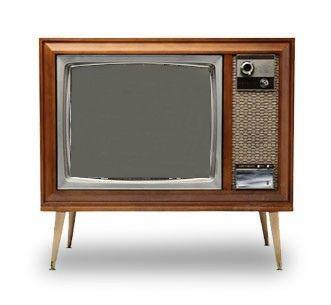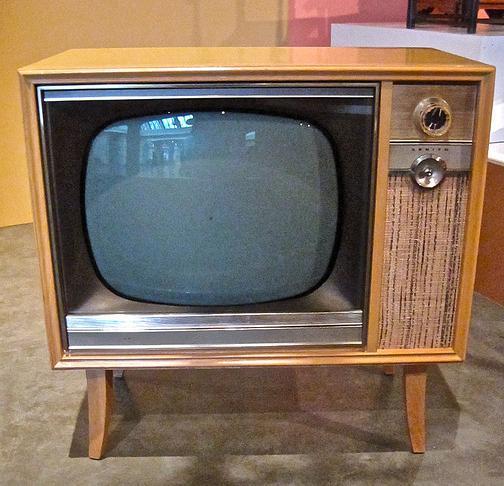The first image is the image on the left, the second image is the image on the right. Evaluate the accuracy of this statement regarding the images: "In at least one image there is a small brown tv with a left and right knobs below the tv screen.". Is it true? Answer yes or no. No. The first image is the image on the left, the second image is the image on the right. Analyze the images presented: Is the assertion "One of the TVs has a screen with rounded corners inset in a light brown boxy console with legs." valid? Answer yes or no. Yes. 